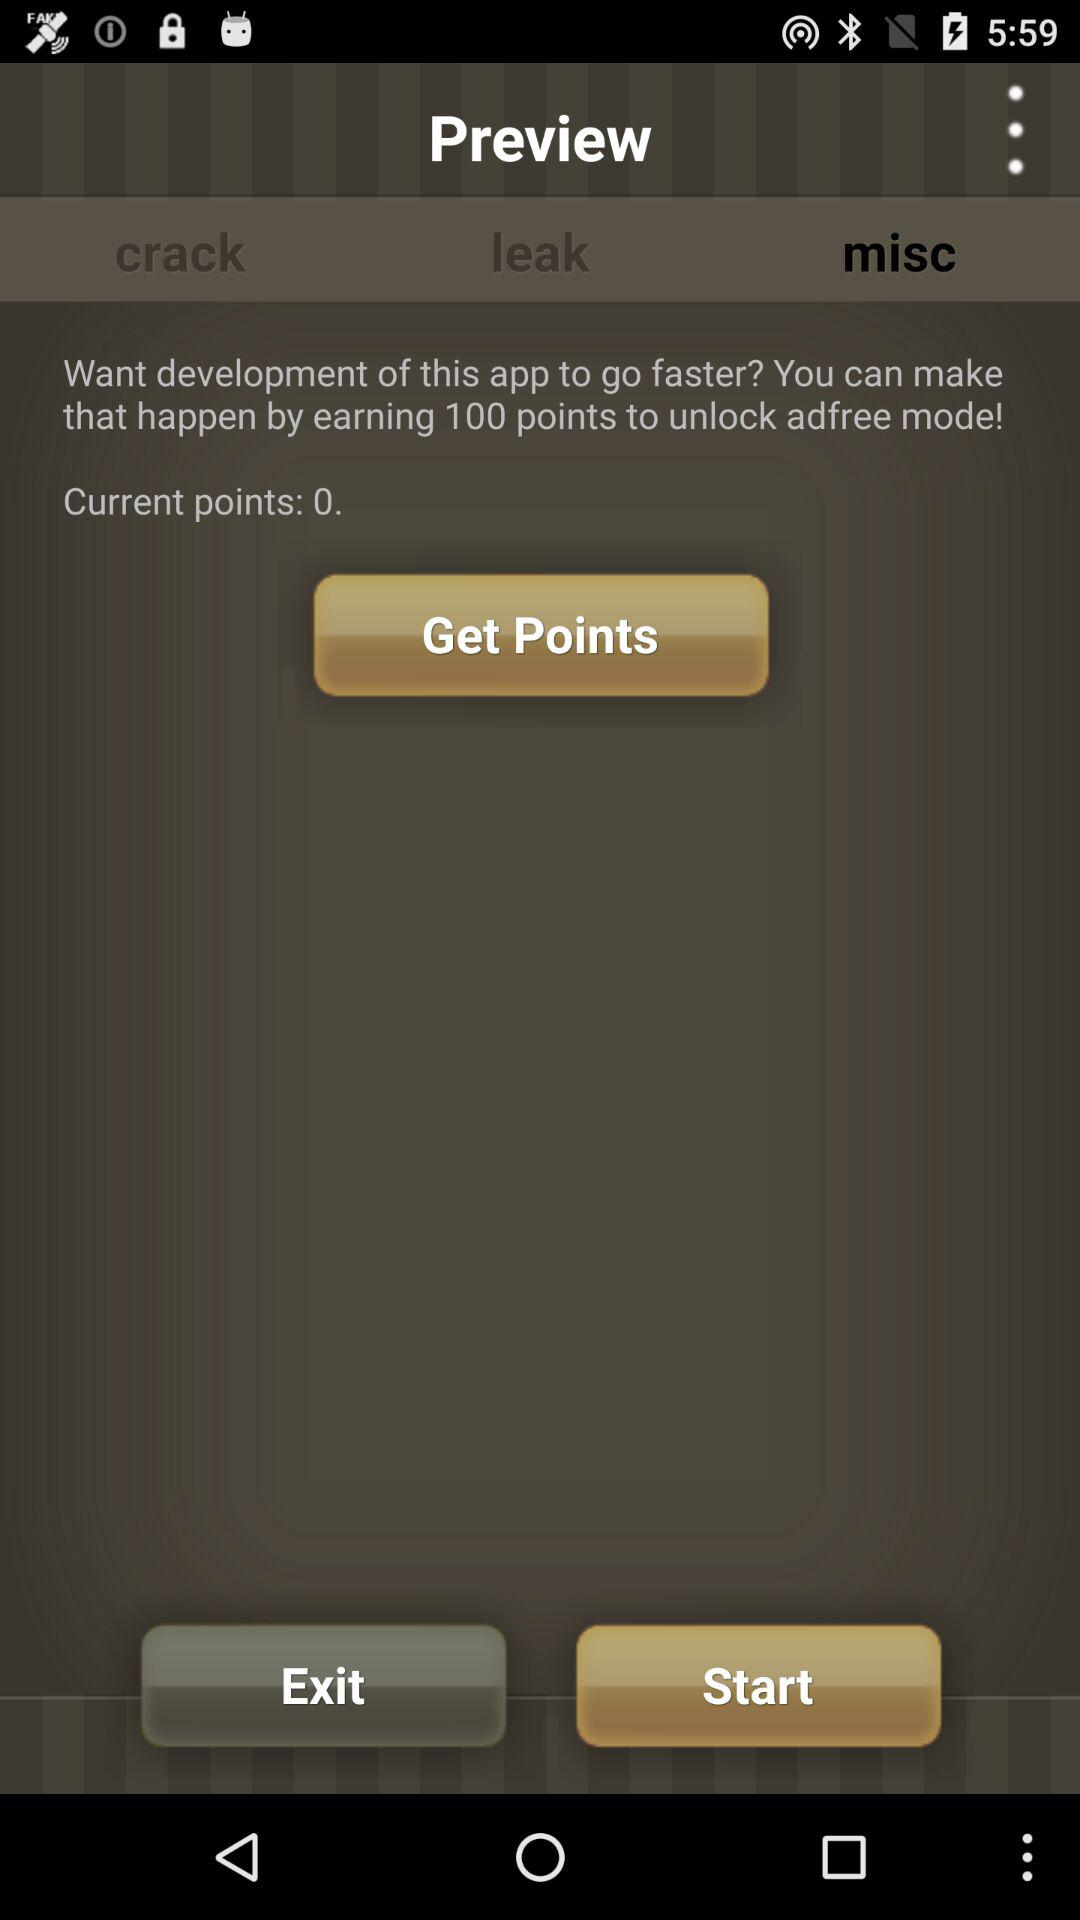Which tab is currently selected? The selected tab is "misc". 